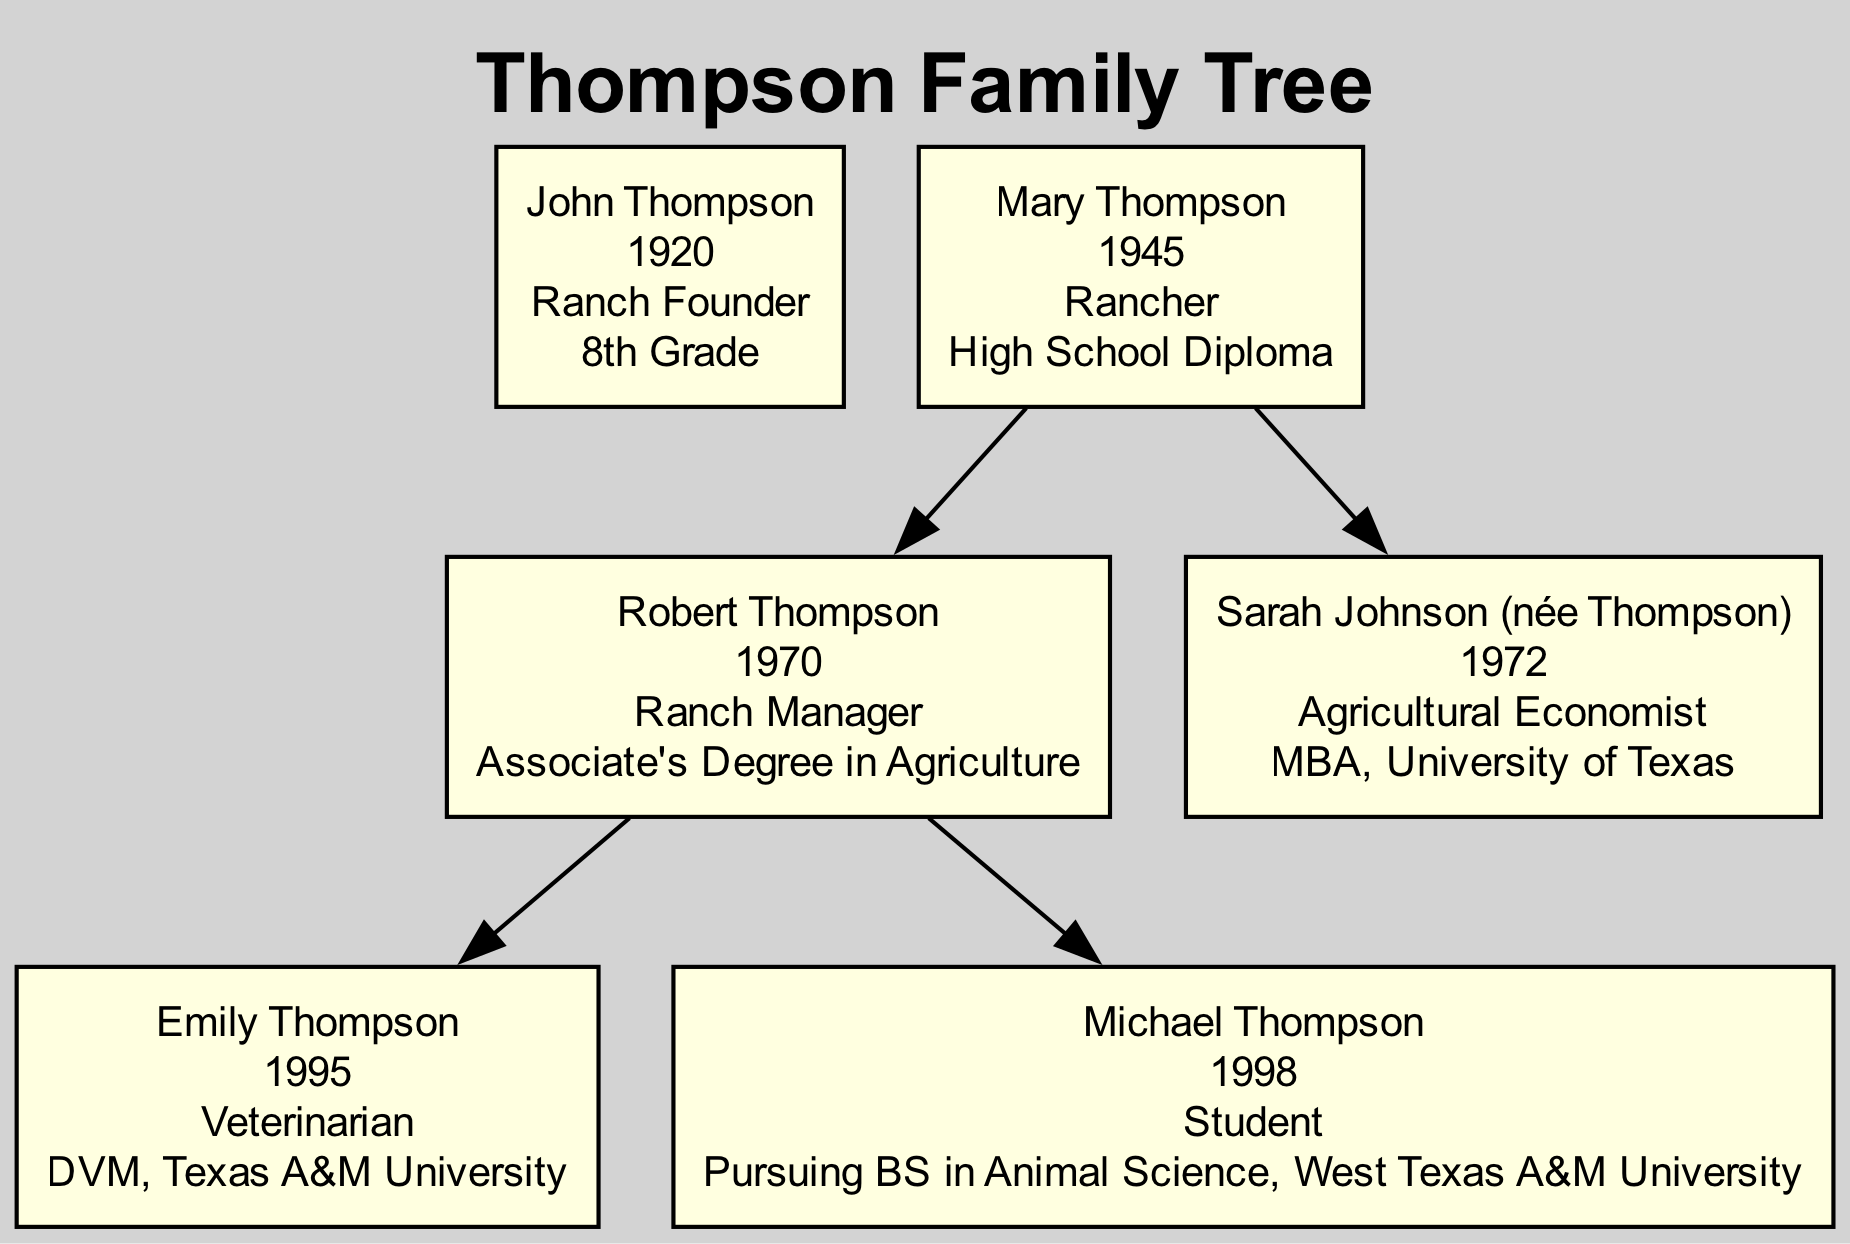What is the birth year of John Thompson? The diagram lists John Thompson as the first generation, showing a birth year of 1920.
Answer: 1920 How many children does Mary Thompson have? By examining the diagram under Mary Thompson, it shows that she has two children: Robert Thompson and Sarah Johnson (née Thompson).
Answer: 2 What occupation does Emily Thompson have? Looking at the diagram, Emily Thompson is listed as a Veterinarian.
Answer: Veterinarian Which educational milestone did Sarah Johnson achieve? The diagram indicates that Sarah Johnson (née Thompson) received an MBA from the University of Texas.
Answer: MBA, University of Texas What is the occupation of Robert Thompson? The diagram specifies that Robert Thompson works as a Ranch Manager.
Answer: Ranch Manager Which generation does Mary Thompson belong to? Upon inspecting the diagram, Mary Thompson is part of the second generation following John Thompson.
Answer: Second Generation What is the educational attainment of Michael Thompson? The diagram states that Michael Thompson is pursuing a Bachelor of Science in Animal Science at West Texas A&M University.
Answer: Pursuing BS in Animal Science, West Texas A&M University Who is the father of Emily Thompson? The diagram shows that Robert Thompson is identified as the parent of Emily Thompson, thus he is her father.
Answer: Robert Thompson Which family member was a Ranch Founder? The diagram identifies John Thompson specifically as the Ranch Founder in the first generation.
Answer: John Thompson 